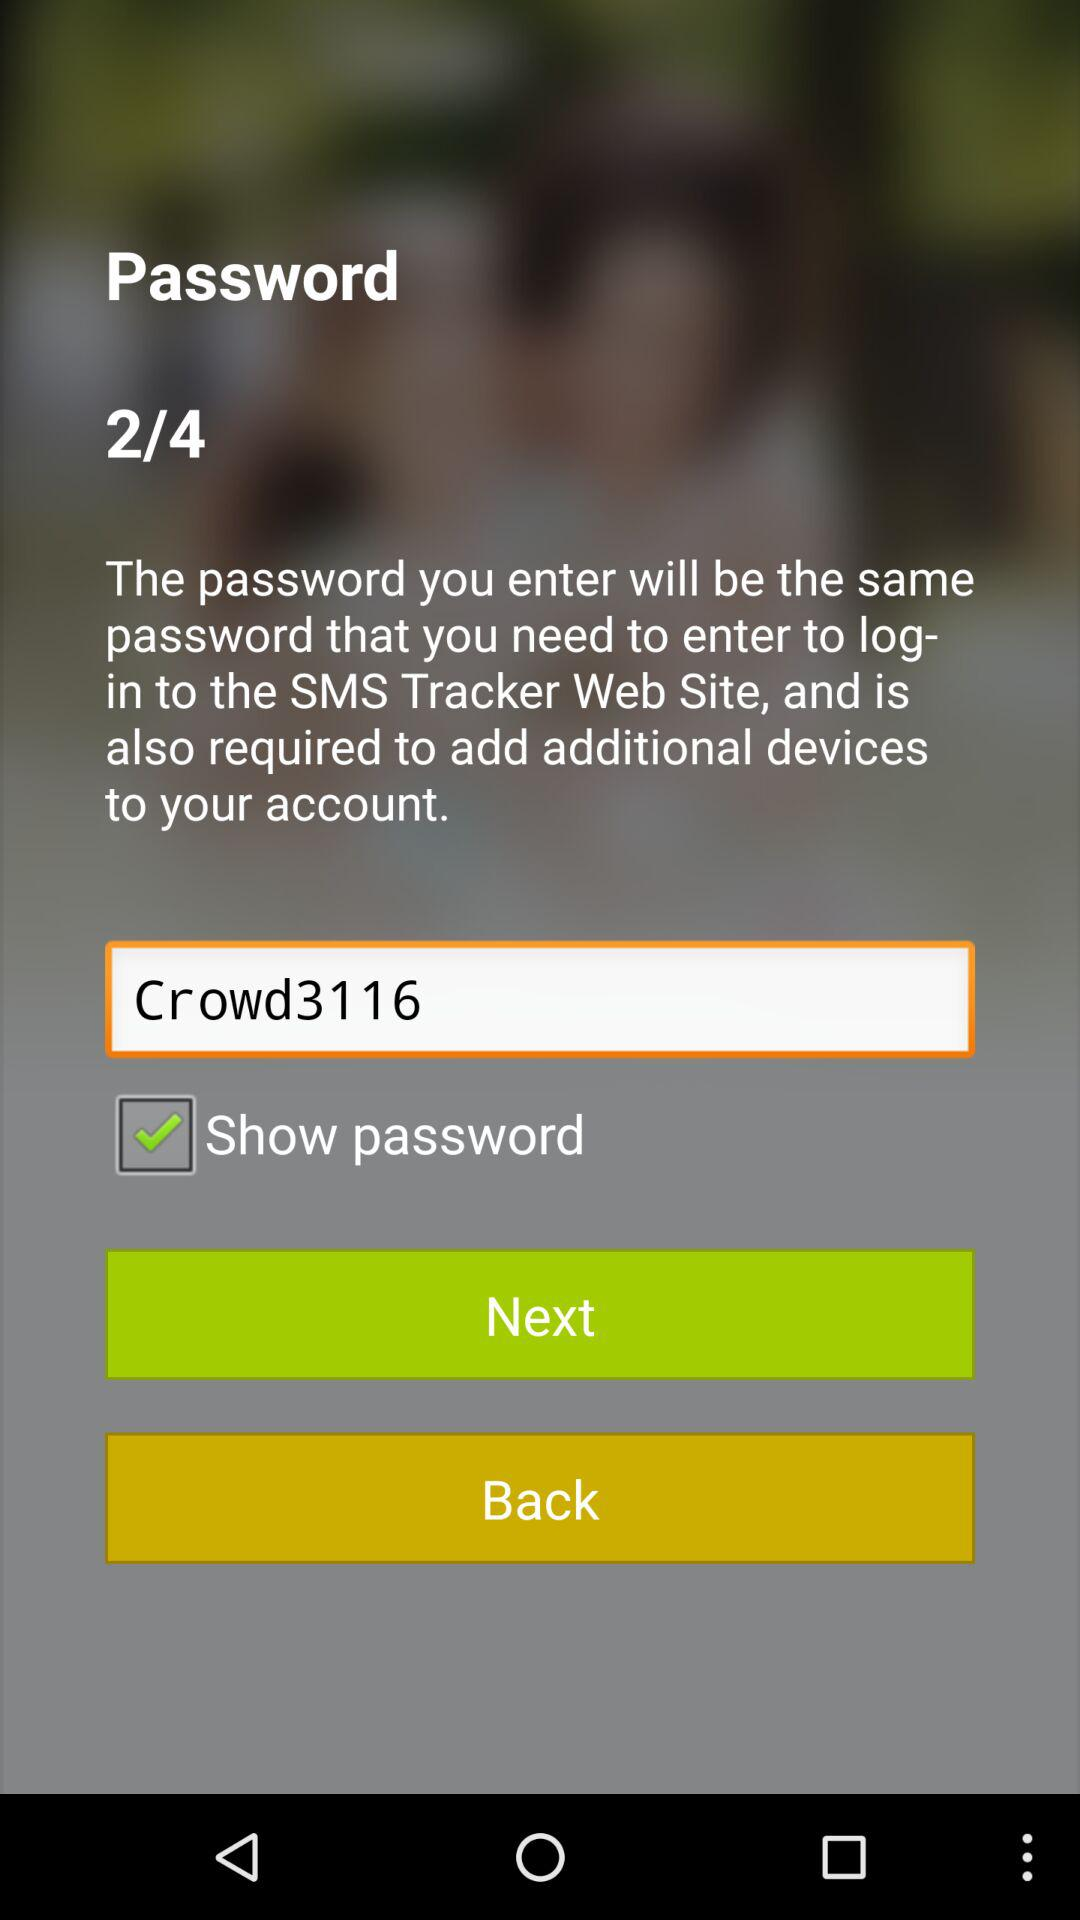What is the password? The password is "Crowd3116". 